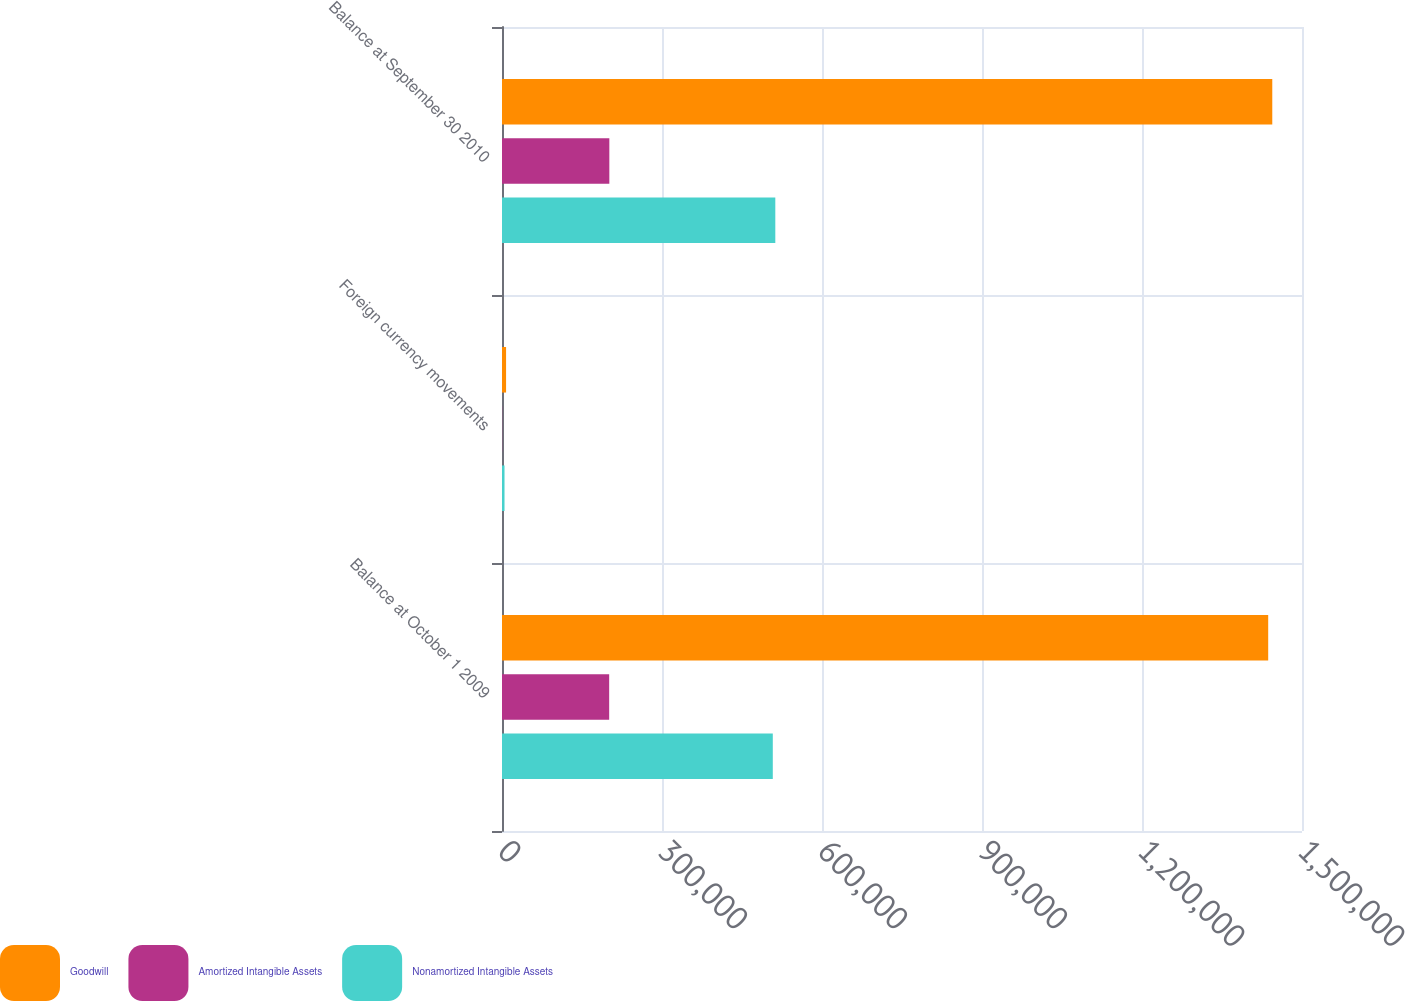Convert chart. <chart><loc_0><loc_0><loc_500><loc_500><stacked_bar_chart><ecel><fcel>Balance at October 1 2009<fcel>Foreign currency movements<fcel>Balance at September 30 2010<nl><fcel>Goodwill<fcel>1.43663e+06<fcel>7643<fcel>1.44427e+06<nl><fcel>Amortized Intangible Assets<fcel>200952<fcel>303<fcel>201255<nl><fcel>Nonamortized Intangible Assets<fcel>507737<fcel>4719<fcel>512456<nl></chart> 